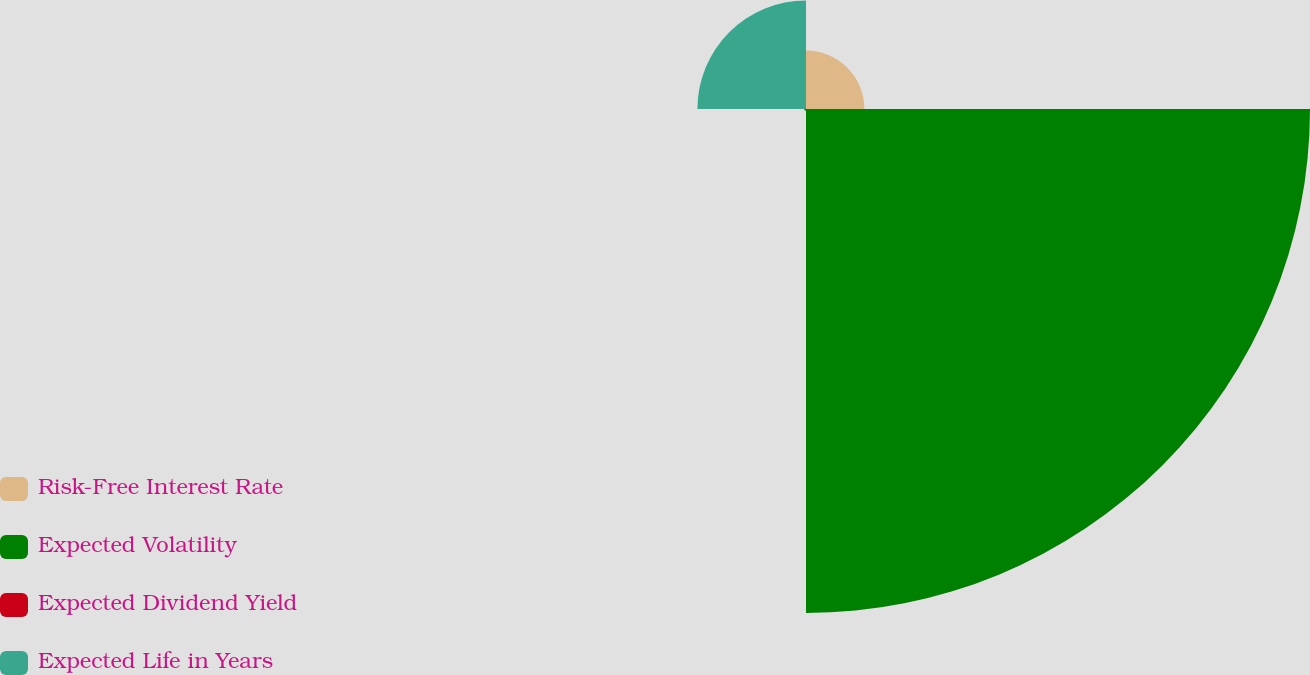Convert chart. <chart><loc_0><loc_0><loc_500><loc_500><pie_chart><fcel>Risk-Free Interest Rate<fcel>Expected Volatility<fcel>Expected Dividend Yield<fcel>Expected Life in Years<nl><fcel>8.68%<fcel>74.92%<fcel>0.26%<fcel>16.14%<nl></chart> 